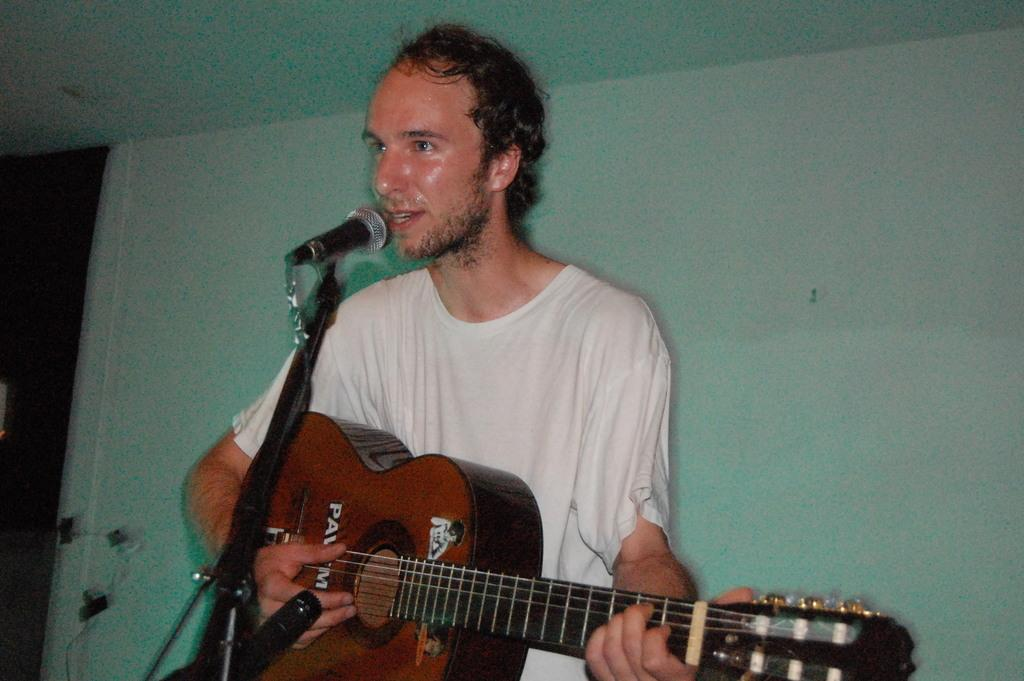What is the man in the image doing? The man is playing the guitar and singing. What instrument is the man holding in the image? The man is holding a guitar in the image. What is the man standing in front of in the image? The man is in front of a microphone in the image. What can be seen in the background of the image? There is a wall in the background of the image. What is the man using to support his guitar in the image? There is a stand in the image that the man is using to support his guitar. How many feet are visible in the image? There is no mention of feet in the image, so it is not possible to determine how many are visible. 